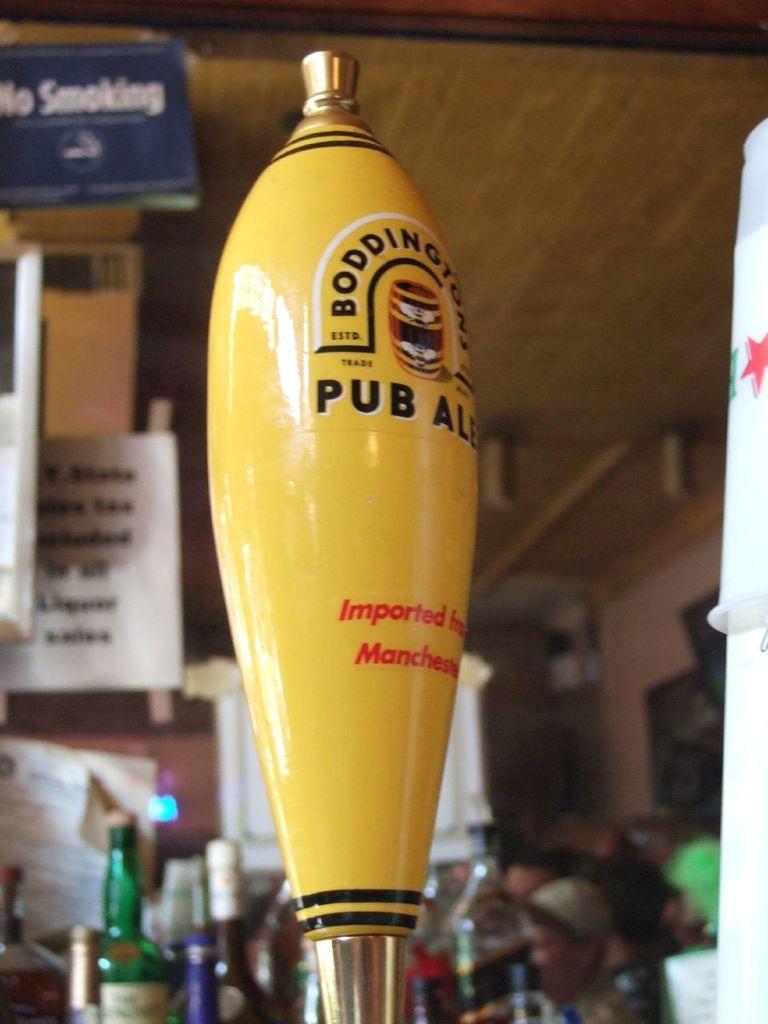Can you describe this image briefly? In this picture there is an object in the foreground and there is text on the object. At the back there are bottles on the table and there are boards and papers and there is text on the boards and there are group of people. At the top there is a wooden roof. On the right side of the image there is an object. 